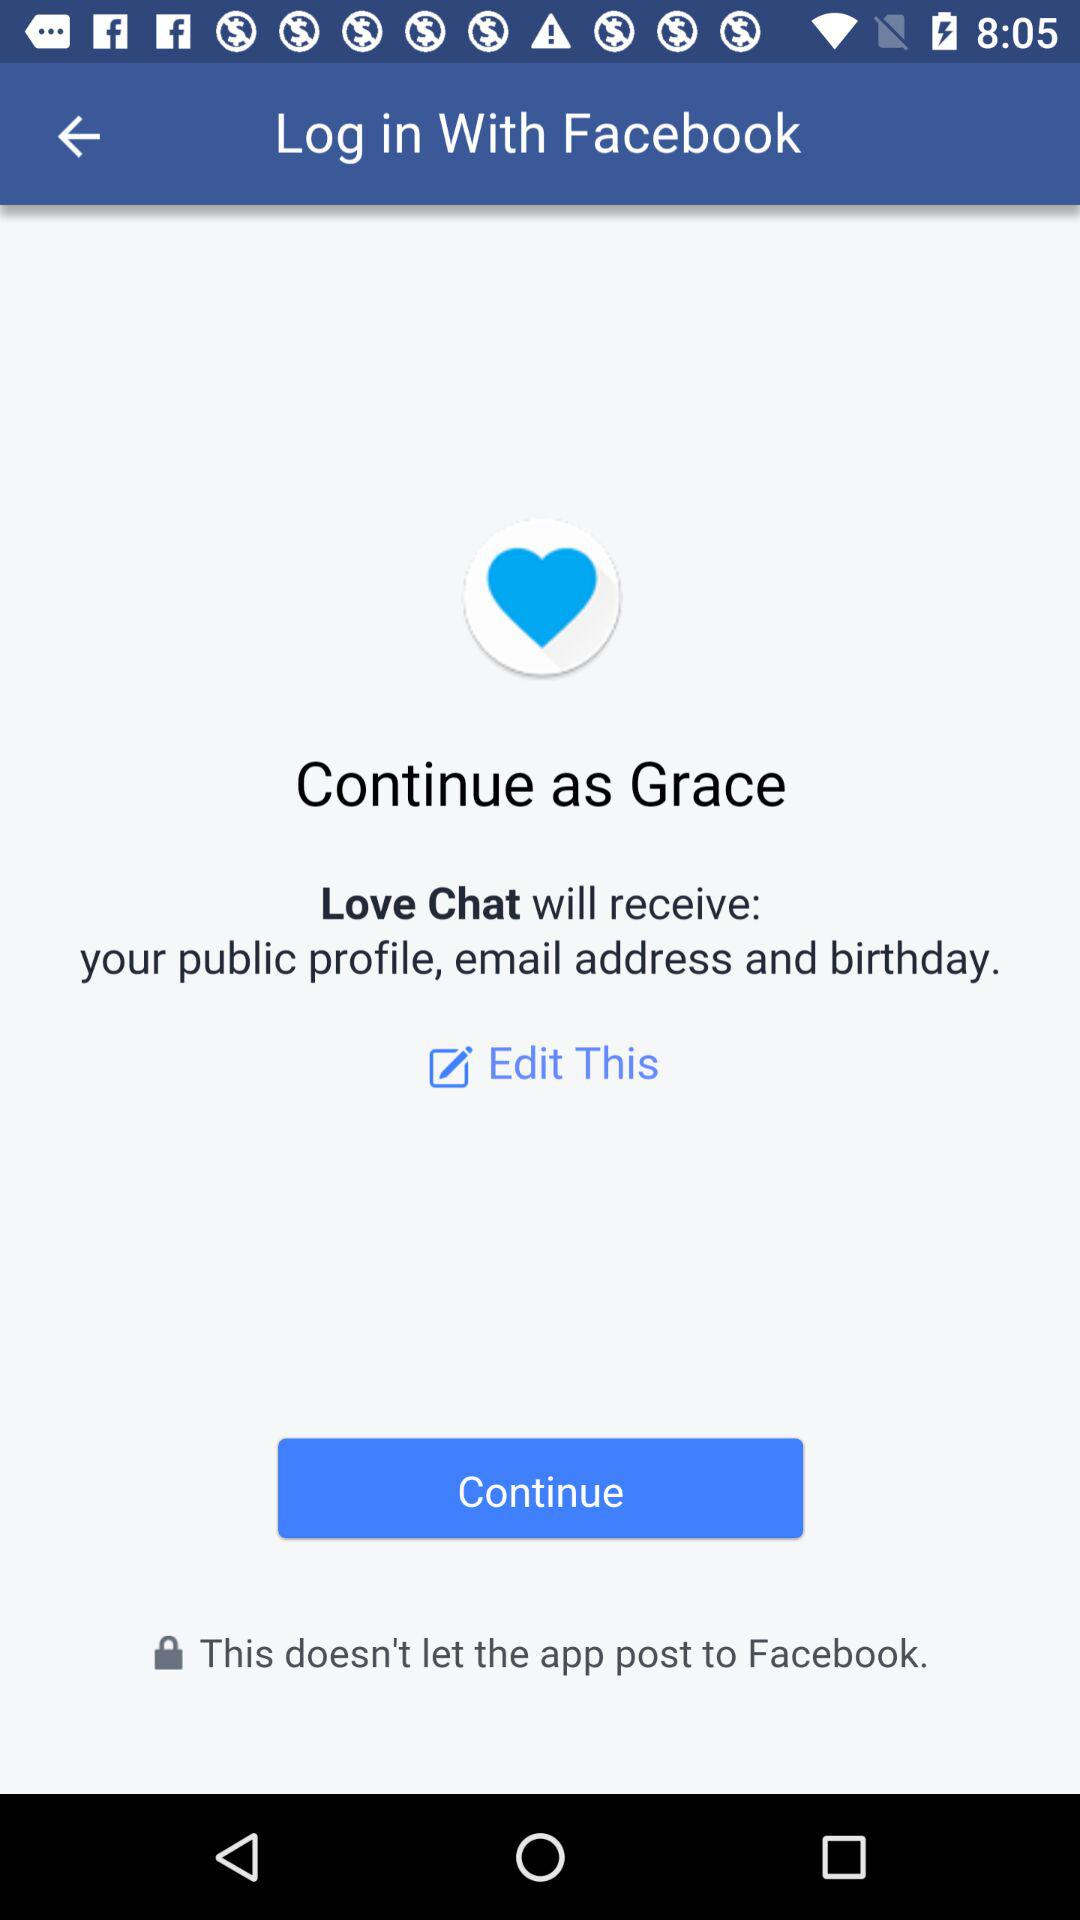How can we log in? You can log in with "Facebook". 